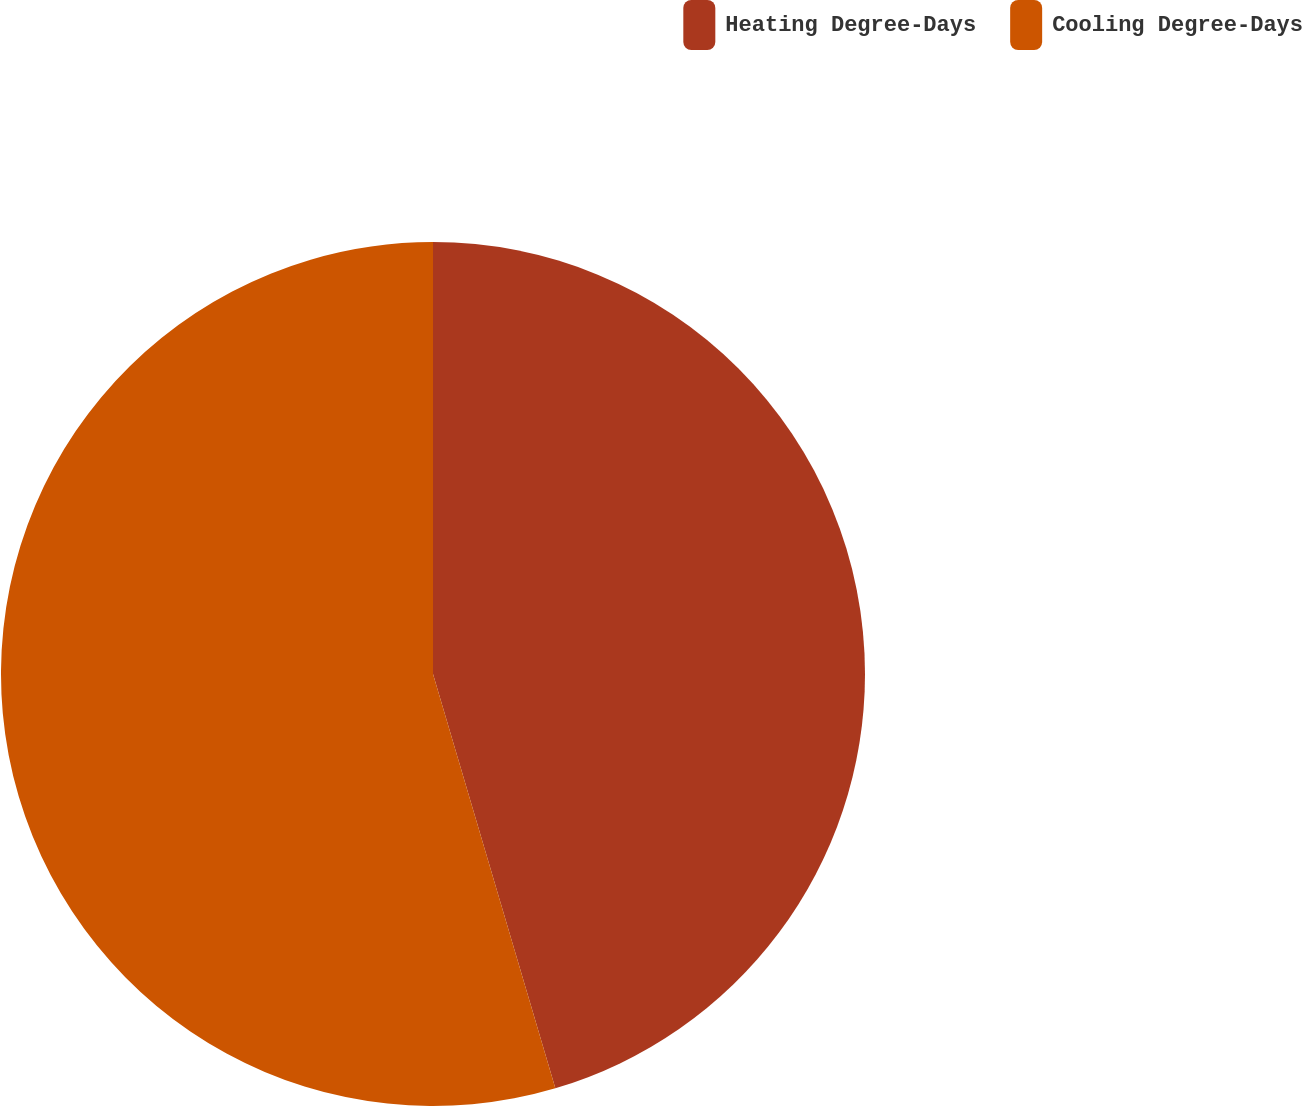Convert chart. <chart><loc_0><loc_0><loc_500><loc_500><pie_chart><fcel>Heating Degree-Days<fcel>Cooling Degree-Days<nl><fcel>45.43%<fcel>54.57%<nl></chart> 